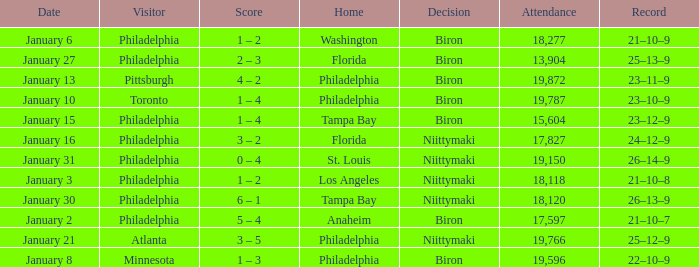What is the decision of the game on January 13? Biron. 